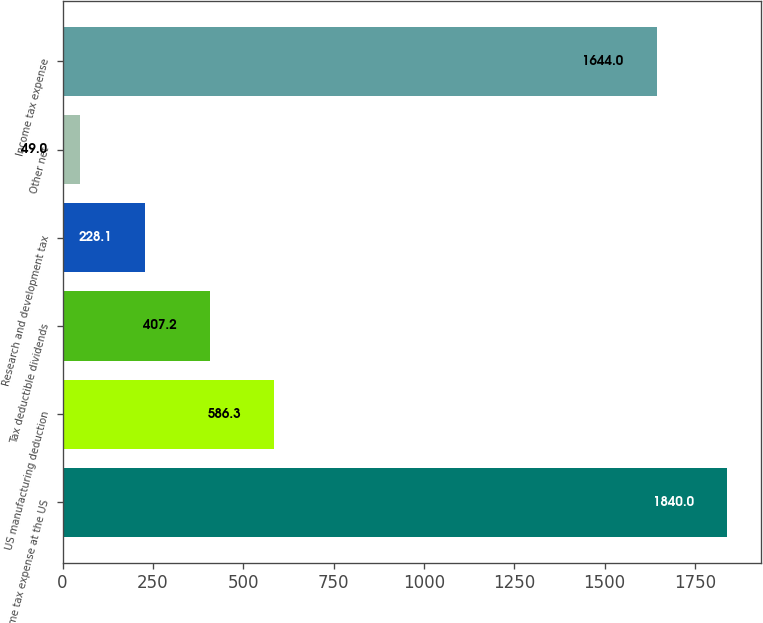Convert chart to OTSL. <chart><loc_0><loc_0><loc_500><loc_500><bar_chart><fcel>Income tax expense at the US<fcel>US manufacturing deduction<fcel>Tax deductible dividends<fcel>Research and development tax<fcel>Other net<fcel>Income tax expense<nl><fcel>1840<fcel>586.3<fcel>407.2<fcel>228.1<fcel>49<fcel>1644<nl></chart> 